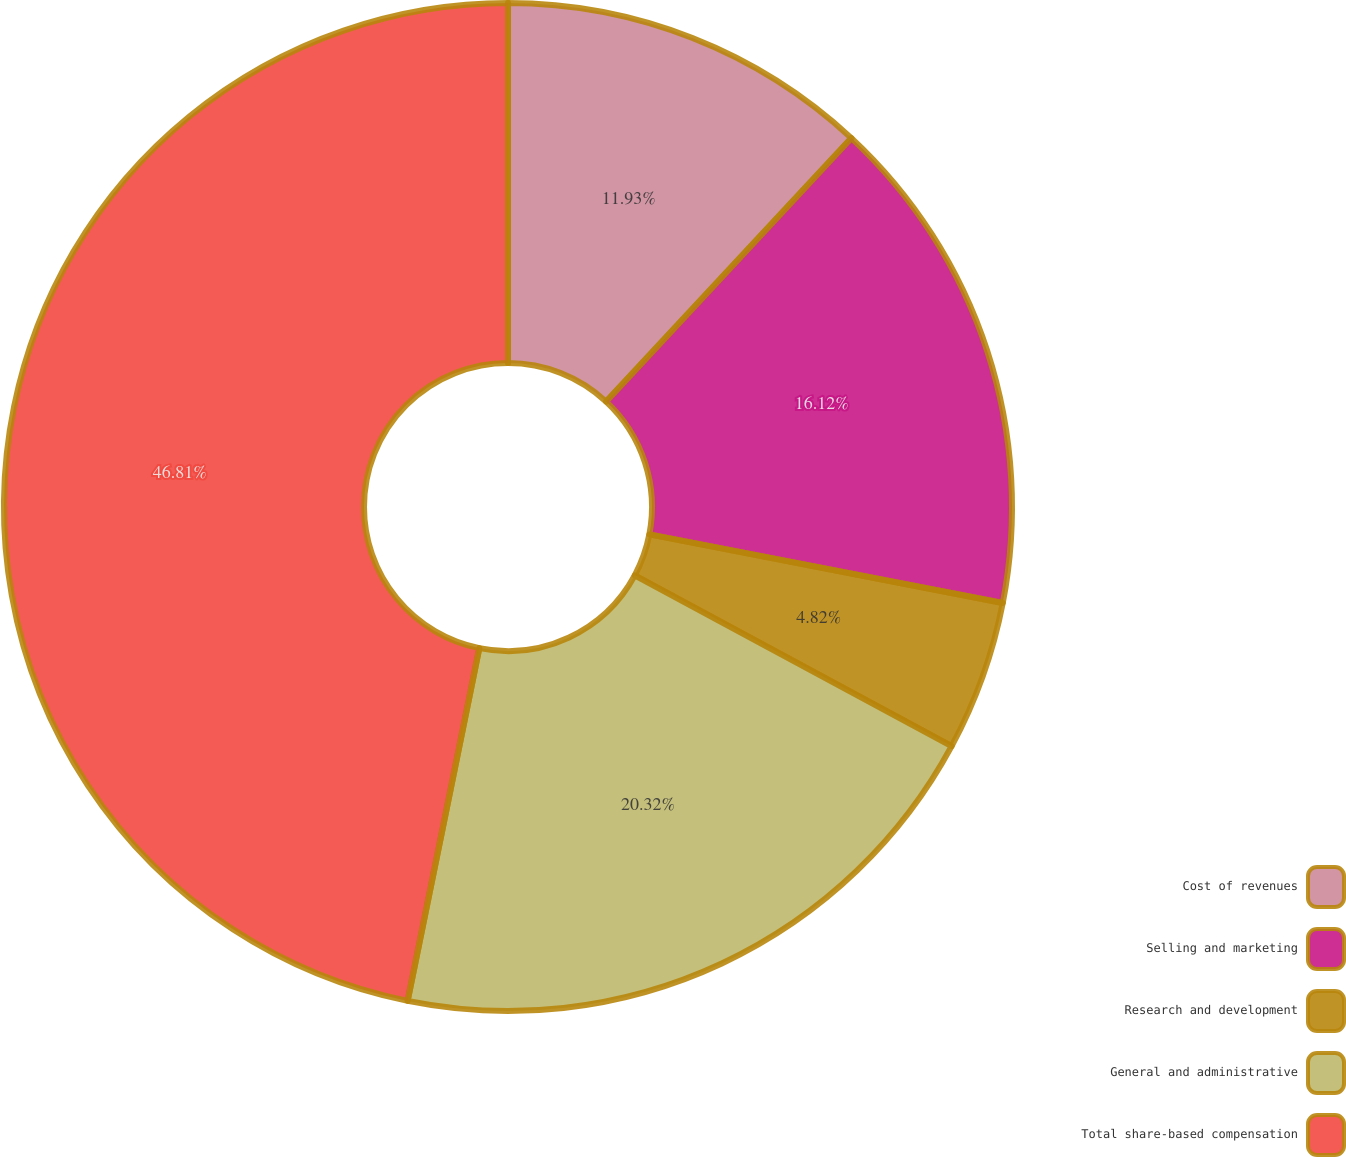Convert chart. <chart><loc_0><loc_0><loc_500><loc_500><pie_chart><fcel>Cost of revenues<fcel>Selling and marketing<fcel>Research and development<fcel>General and administrative<fcel>Total share-based compensation<nl><fcel>11.93%<fcel>16.12%<fcel>4.82%<fcel>20.32%<fcel>46.81%<nl></chart> 